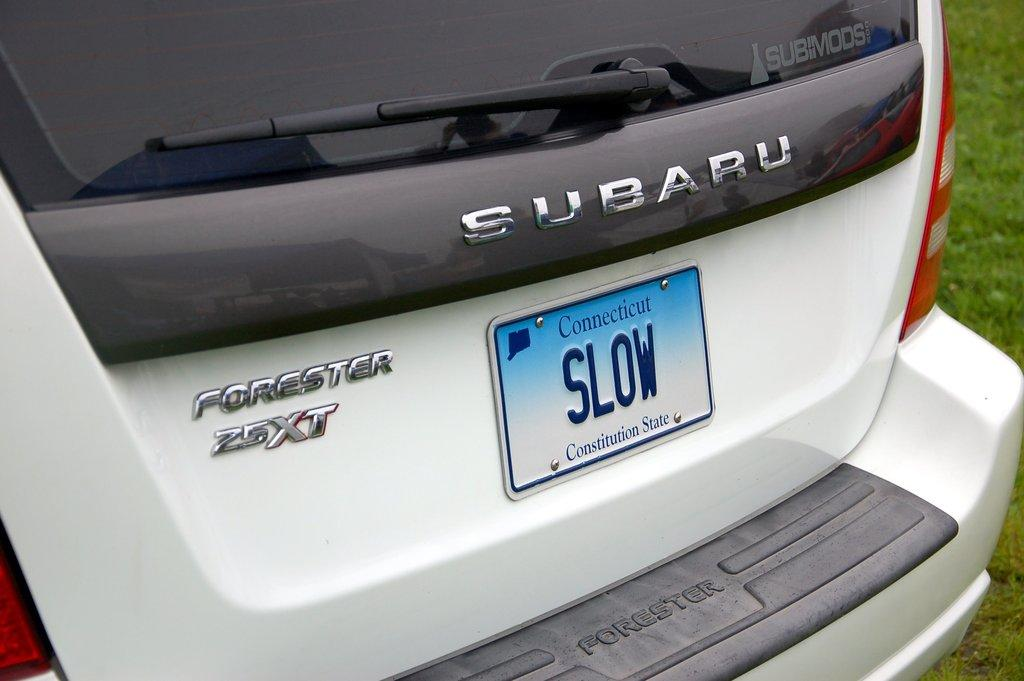<image>
Give a short and clear explanation of the subsequent image. A Subaru has a Connecticut license plate that says SLOW 